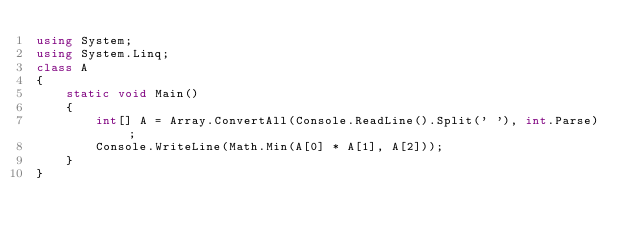Convert code to text. <code><loc_0><loc_0><loc_500><loc_500><_C#_>using System;
using System.Linq;
class A
{
    static void Main()
    {
        int[] A = Array.ConvertAll(Console.ReadLine().Split(' '), int.Parse) ;
        Console.WriteLine(Math.Min(A[0] * A[1], A[2]));
    }
}</code> 